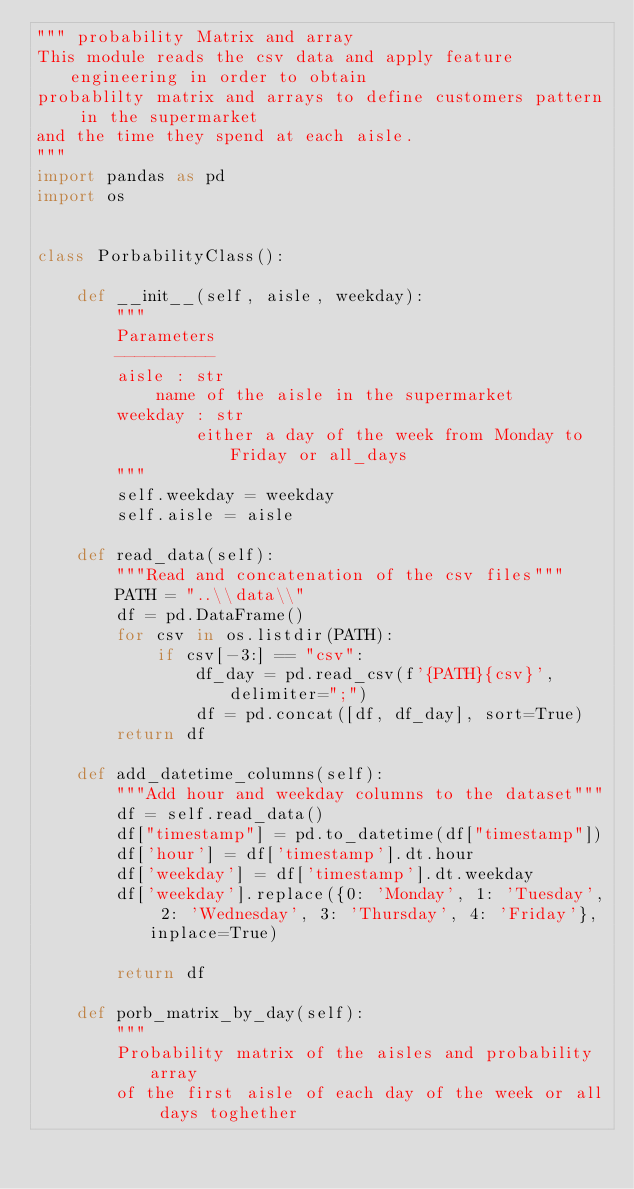Convert code to text. <code><loc_0><loc_0><loc_500><loc_500><_Python_>""" probability Matrix and array
This module reads the csv data and apply feature engineering in order to obtain
probablilty matrix and arrays to define customers pattern in the supermarket
and the time they spend at each aisle.
"""
import pandas as pd
import os


class PorbabilityClass():

    def __init__(self, aisle, weekday):
        """
        Parameters
        ----------
        aisle : str
            name of the aisle in the supermarket
        weekday : str
                either a day of the week from Monday to Friday or all_days
        """
        self.weekday = weekday
        self.aisle = aisle

    def read_data(self):
        """Read and concatenation of the csv files"""
        PATH = "..\\data\\"
        df = pd.DataFrame()
        for csv in os.listdir(PATH):
            if csv[-3:] == "csv":
                df_day = pd.read_csv(f'{PATH}{csv}', delimiter=";")
                df = pd.concat([df, df_day], sort=True)
        return df

    def add_datetime_columns(self):
        """Add hour and weekday columns to the dataset"""
        df = self.read_data()
        df["timestamp"] = pd.to_datetime(df["timestamp"])
        df['hour'] = df['timestamp'].dt.hour
        df['weekday'] = df['timestamp'].dt.weekday
        df['weekday'].replace({0: 'Monday', 1: 'Tuesday', 2: 'Wednesday', 3: 'Thursday', 4: 'Friday'}, inplace=True)

        return df

    def porb_matrix_by_day(self):
        """
        Probability matrix of the aisles and probability array
        of the first aisle of each day of the week or all days toghether
</code> 